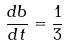Convert formula to latex. <formula><loc_0><loc_0><loc_500><loc_500>\frac { d b } { d t } = \frac { 1 } { 3 }</formula> 